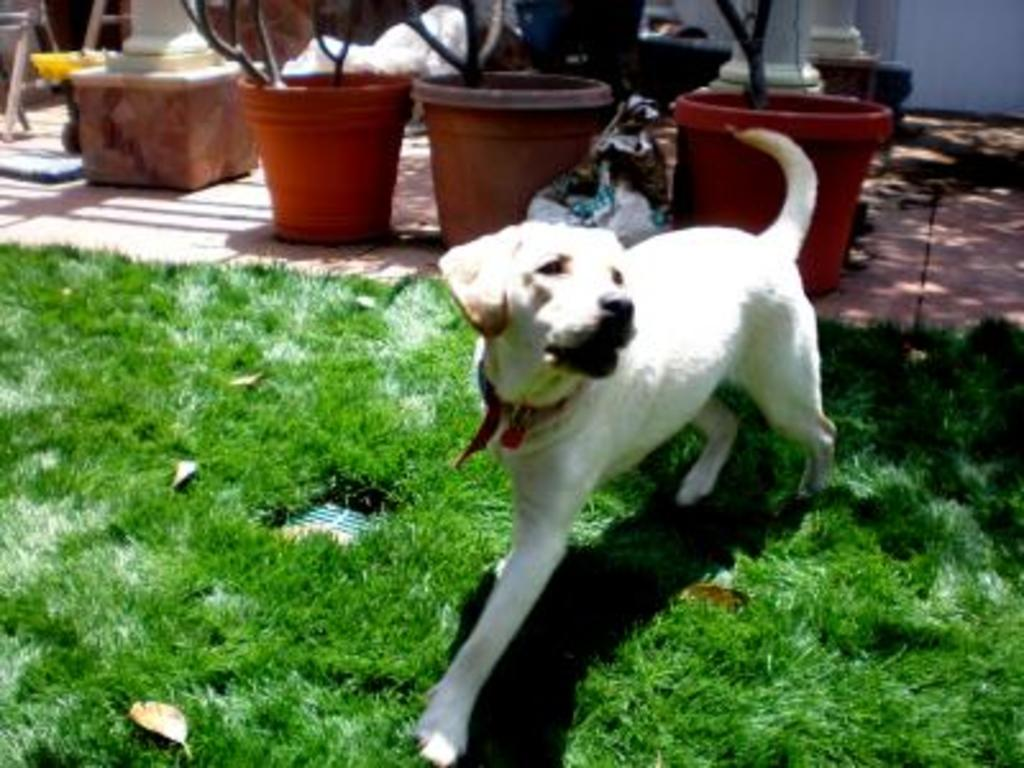What type of animal is on the grass lawn in the image? There is a white dog on the grass lawn in the image. What can be seen in the background of the image? There are pots with plants in the background. Are there any other objects or features visible in the background? Yes, there are other items visible in the background. Is the dog wearing a crown in the image? No, the dog is not wearing a crown in the image. What type of art can be seen hanging on the wall in the background? There is no art visible on the wall in the background of the image. 